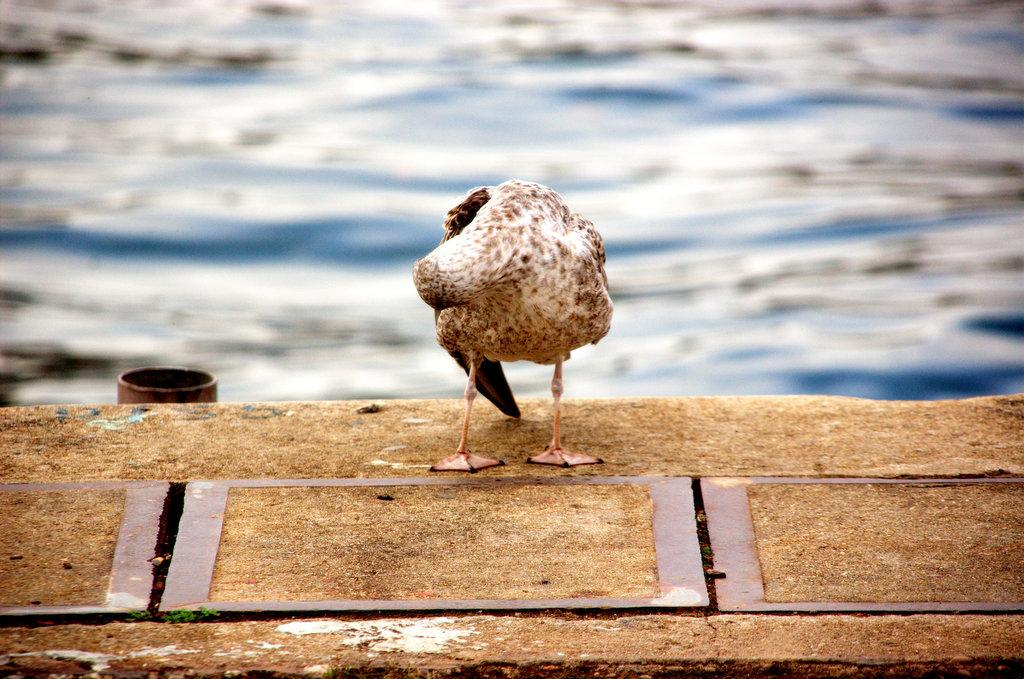What type of animal can be seen in the image? There is a bird in the image. What is the bird doing in the image? The bird is standing on a surface. What can be seen in the background of the image? There is water visible behind the bird. What type of cats can be seen playing with the bird in the image? There are no cats present in the image, and the bird is not interacting with any other animals. 